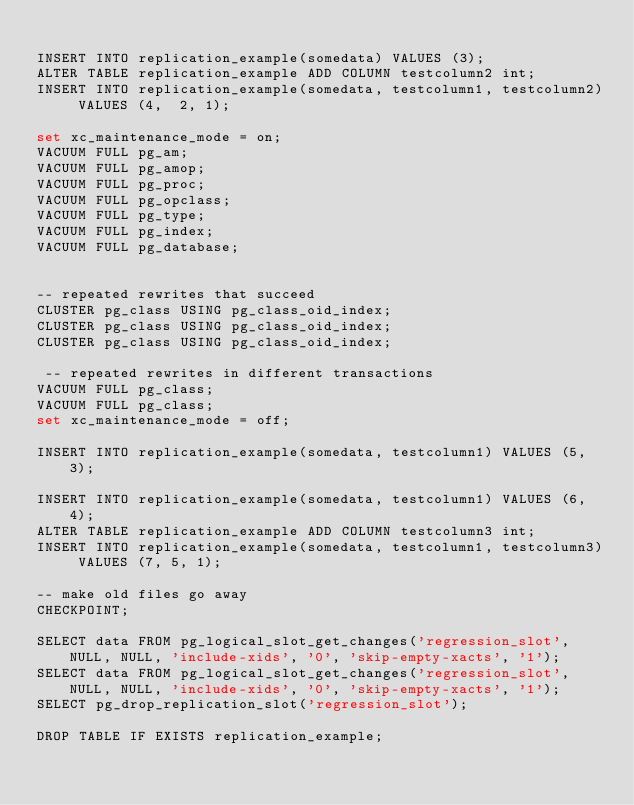Convert code to text. <code><loc_0><loc_0><loc_500><loc_500><_SQL_>
INSERT INTO replication_example(somedata) VALUES (3);
ALTER TABLE replication_example ADD COLUMN testcolumn2 int;
INSERT INTO replication_example(somedata, testcolumn1, testcolumn2) VALUES (4,  2, 1);

set xc_maintenance_mode = on;
VACUUM FULL pg_am;
VACUUM FULL pg_amop;
VACUUM FULL pg_proc;
VACUUM FULL pg_opclass;
VACUUM FULL pg_type;
VACUUM FULL pg_index;
VACUUM FULL pg_database;


-- repeated rewrites that succeed
CLUSTER pg_class USING pg_class_oid_index;
CLUSTER pg_class USING pg_class_oid_index;
CLUSTER pg_class USING pg_class_oid_index;

 -- repeated rewrites in different transactions
VACUUM FULL pg_class;
VACUUM FULL pg_class;
set xc_maintenance_mode = off;

INSERT INTO replication_example(somedata, testcolumn1) VALUES (5, 3);

INSERT INTO replication_example(somedata, testcolumn1) VALUES (6, 4);
ALTER TABLE replication_example ADD COLUMN testcolumn3 int;
INSERT INTO replication_example(somedata, testcolumn1, testcolumn3) VALUES (7, 5, 1);

-- make old files go away
CHECKPOINT;

SELECT data FROM pg_logical_slot_get_changes('regression_slot', NULL, NULL, 'include-xids', '0', 'skip-empty-xacts', '1');
SELECT data FROM pg_logical_slot_get_changes('regression_slot', NULL, NULL, 'include-xids', '0', 'skip-empty-xacts', '1');
SELECT pg_drop_replication_slot('regression_slot');

DROP TABLE IF EXISTS replication_example;

</code> 